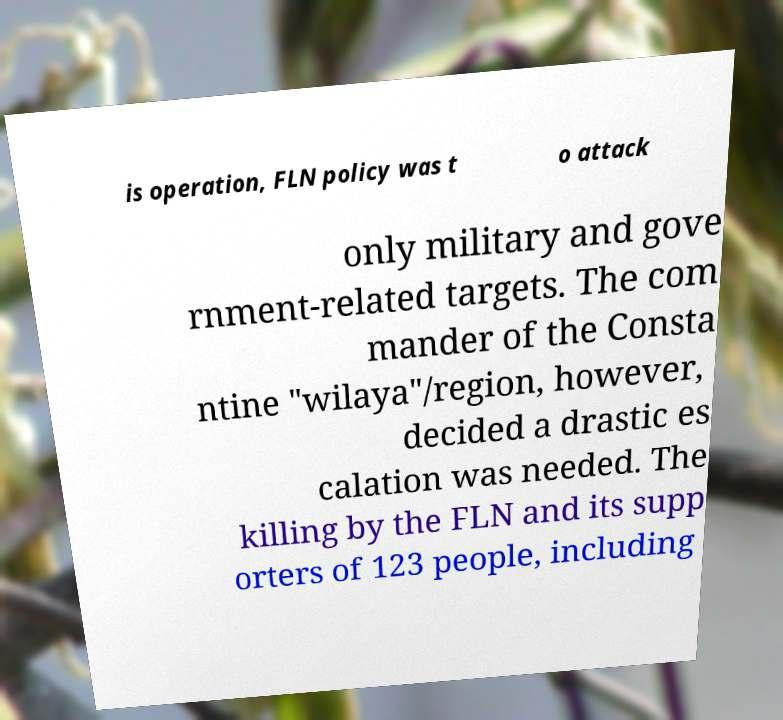I need the written content from this picture converted into text. Can you do that? is operation, FLN policy was t o attack only military and gove rnment-related targets. The com mander of the Consta ntine "wilaya"/region, however, decided a drastic es calation was needed. The killing by the FLN and its supp orters of 123 people, including 